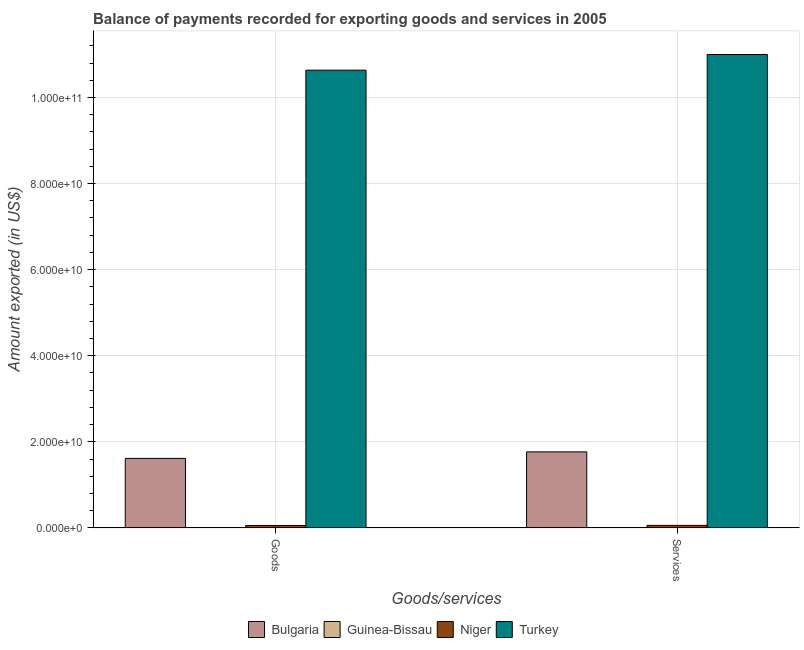How many different coloured bars are there?
Offer a terse response. 4. How many groups of bars are there?
Offer a terse response. 2. Are the number of bars per tick equal to the number of legend labels?
Your answer should be compact. Yes. Are the number of bars on each tick of the X-axis equal?
Make the answer very short. Yes. What is the label of the 2nd group of bars from the left?
Make the answer very short. Services. What is the amount of goods exported in Bulgaria?
Provide a succinct answer. 1.62e+1. Across all countries, what is the maximum amount of goods exported?
Ensure brevity in your answer.  1.06e+11. Across all countries, what is the minimum amount of goods exported?
Offer a very short reply. 9.48e+07. In which country was the amount of services exported maximum?
Provide a succinct answer. Turkey. In which country was the amount of services exported minimum?
Offer a terse response. Guinea-Bissau. What is the total amount of services exported in the graph?
Provide a short and direct response. 1.28e+11. What is the difference between the amount of services exported in Niger and that in Guinea-Bissau?
Offer a very short reply. 5.07e+08. What is the difference between the amount of services exported in Turkey and the amount of goods exported in Guinea-Bissau?
Offer a very short reply. 1.10e+11. What is the average amount of goods exported per country?
Make the answer very short. 3.08e+1. What is the difference between the amount of goods exported and amount of services exported in Guinea-Bissau?
Your answer should be very brief. -4.42e+05. What is the ratio of the amount of goods exported in Bulgaria to that in Niger?
Offer a terse response. 28.59. What does the 2nd bar from the left in Services represents?
Ensure brevity in your answer.  Guinea-Bissau. What does the 3rd bar from the right in Services represents?
Make the answer very short. Guinea-Bissau. How many bars are there?
Provide a short and direct response. 8. Are the values on the major ticks of Y-axis written in scientific E-notation?
Provide a succinct answer. Yes. Does the graph contain any zero values?
Provide a succinct answer. No. Where does the legend appear in the graph?
Offer a terse response. Bottom center. How many legend labels are there?
Give a very brief answer. 4. What is the title of the graph?
Ensure brevity in your answer.  Balance of payments recorded for exporting goods and services in 2005. What is the label or title of the X-axis?
Your answer should be compact. Goods/services. What is the label or title of the Y-axis?
Offer a terse response. Amount exported (in US$). What is the Amount exported (in US$) in Bulgaria in Goods?
Make the answer very short. 1.62e+1. What is the Amount exported (in US$) in Guinea-Bissau in Goods?
Offer a very short reply. 9.48e+07. What is the Amount exported (in US$) in Niger in Goods?
Ensure brevity in your answer.  5.65e+08. What is the Amount exported (in US$) in Turkey in Goods?
Offer a very short reply. 1.06e+11. What is the Amount exported (in US$) of Bulgaria in Services?
Your answer should be compact. 1.77e+1. What is the Amount exported (in US$) of Guinea-Bissau in Services?
Provide a short and direct response. 9.52e+07. What is the Amount exported (in US$) in Niger in Services?
Make the answer very short. 6.02e+08. What is the Amount exported (in US$) of Turkey in Services?
Keep it short and to the point. 1.10e+11. Across all Goods/services, what is the maximum Amount exported (in US$) in Bulgaria?
Keep it short and to the point. 1.77e+1. Across all Goods/services, what is the maximum Amount exported (in US$) of Guinea-Bissau?
Offer a very short reply. 9.52e+07. Across all Goods/services, what is the maximum Amount exported (in US$) in Niger?
Give a very brief answer. 6.02e+08. Across all Goods/services, what is the maximum Amount exported (in US$) in Turkey?
Keep it short and to the point. 1.10e+11. Across all Goods/services, what is the minimum Amount exported (in US$) of Bulgaria?
Offer a terse response. 1.62e+1. Across all Goods/services, what is the minimum Amount exported (in US$) of Guinea-Bissau?
Ensure brevity in your answer.  9.48e+07. Across all Goods/services, what is the minimum Amount exported (in US$) of Niger?
Ensure brevity in your answer.  5.65e+08. Across all Goods/services, what is the minimum Amount exported (in US$) of Turkey?
Offer a very short reply. 1.06e+11. What is the total Amount exported (in US$) in Bulgaria in the graph?
Your answer should be very brief. 3.38e+1. What is the total Amount exported (in US$) in Guinea-Bissau in the graph?
Your answer should be compact. 1.90e+08. What is the total Amount exported (in US$) of Niger in the graph?
Provide a succinct answer. 1.17e+09. What is the total Amount exported (in US$) of Turkey in the graph?
Ensure brevity in your answer.  2.16e+11. What is the difference between the Amount exported (in US$) in Bulgaria in Goods and that in Services?
Offer a very short reply. -1.52e+09. What is the difference between the Amount exported (in US$) in Guinea-Bissau in Goods and that in Services?
Offer a very short reply. -4.42e+05. What is the difference between the Amount exported (in US$) of Niger in Goods and that in Services?
Provide a succinct answer. -3.71e+07. What is the difference between the Amount exported (in US$) of Turkey in Goods and that in Services?
Your answer should be very brief. -3.64e+09. What is the difference between the Amount exported (in US$) in Bulgaria in Goods and the Amount exported (in US$) in Guinea-Bissau in Services?
Provide a succinct answer. 1.61e+1. What is the difference between the Amount exported (in US$) of Bulgaria in Goods and the Amount exported (in US$) of Niger in Services?
Your answer should be very brief. 1.56e+1. What is the difference between the Amount exported (in US$) of Bulgaria in Goods and the Amount exported (in US$) of Turkey in Services?
Give a very brief answer. -9.38e+1. What is the difference between the Amount exported (in US$) in Guinea-Bissau in Goods and the Amount exported (in US$) in Niger in Services?
Your answer should be compact. -5.07e+08. What is the difference between the Amount exported (in US$) of Guinea-Bissau in Goods and the Amount exported (in US$) of Turkey in Services?
Give a very brief answer. -1.10e+11. What is the difference between the Amount exported (in US$) in Niger in Goods and the Amount exported (in US$) in Turkey in Services?
Ensure brevity in your answer.  -1.09e+11. What is the average Amount exported (in US$) of Bulgaria per Goods/services?
Offer a terse response. 1.69e+1. What is the average Amount exported (in US$) in Guinea-Bissau per Goods/services?
Keep it short and to the point. 9.50e+07. What is the average Amount exported (in US$) in Niger per Goods/services?
Keep it short and to the point. 5.84e+08. What is the average Amount exported (in US$) of Turkey per Goods/services?
Your response must be concise. 1.08e+11. What is the difference between the Amount exported (in US$) of Bulgaria and Amount exported (in US$) of Guinea-Bissau in Goods?
Provide a succinct answer. 1.61e+1. What is the difference between the Amount exported (in US$) of Bulgaria and Amount exported (in US$) of Niger in Goods?
Offer a terse response. 1.56e+1. What is the difference between the Amount exported (in US$) of Bulgaria and Amount exported (in US$) of Turkey in Goods?
Offer a terse response. -9.02e+1. What is the difference between the Amount exported (in US$) of Guinea-Bissau and Amount exported (in US$) of Niger in Goods?
Offer a terse response. -4.70e+08. What is the difference between the Amount exported (in US$) of Guinea-Bissau and Amount exported (in US$) of Turkey in Goods?
Your answer should be very brief. -1.06e+11. What is the difference between the Amount exported (in US$) in Niger and Amount exported (in US$) in Turkey in Goods?
Make the answer very short. -1.06e+11. What is the difference between the Amount exported (in US$) in Bulgaria and Amount exported (in US$) in Guinea-Bissau in Services?
Your response must be concise. 1.76e+1. What is the difference between the Amount exported (in US$) of Bulgaria and Amount exported (in US$) of Niger in Services?
Your answer should be compact. 1.71e+1. What is the difference between the Amount exported (in US$) in Bulgaria and Amount exported (in US$) in Turkey in Services?
Provide a succinct answer. -9.23e+1. What is the difference between the Amount exported (in US$) of Guinea-Bissau and Amount exported (in US$) of Niger in Services?
Provide a short and direct response. -5.07e+08. What is the difference between the Amount exported (in US$) in Guinea-Bissau and Amount exported (in US$) in Turkey in Services?
Make the answer very short. -1.10e+11. What is the difference between the Amount exported (in US$) in Niger and Amount exported (in US$) in Turkey in Services?
Provide a succinct answer. -1.09e+11. What is the ratio of the Amount exported (in US$) of Bulgaria in Goods to that in Services?
Keep it short and to the point. 0.91. What is the ratio of the Amount exported (in US$) of Niger in Goods to that in Services?
Provide a short and direct response. 0.94. What is the ratio of the Amount exported (in US$) in Turkey in Goods to that in Services?
Give a very brief answer. 0.97. What is the difference between the highest and the second highest Amount exported (in US$) of Bulgaria?
Make the answer very short. 1.52e+09. What is the difference between the highest and the second highest Amount exported (in US$) of Guinea-Bissau?
Provide a succinct answer. 4.42e+05. What is the difference between the highest and the second highest Amount exported (in US$) in Niger?
Keep it short and to the point. 3.71e+07. What is the difference between the highest and the second highest Amount exported (in US$) in Turkey?
Ensure brevity in your answer.  3.64e+09. What is the difference between the highest and the lowest Amount exported (in US$) of Bulgaria?
Give a very brief answer. 1.52e+09. What is the difference between the highest and the lowest Amount exported (in US$) of Guinea-Bissau?
Your answer should be very brief. 4.42e+05. What is the difference between the highest and the lowest Amount exported (in US$) of Niger?
Provide a succinct answer. 3.71e+07. What is the difference between the highest and the lowest Amount exported (in US$) in Turkey?
Provide a succinct answer. 3.64e+09. 